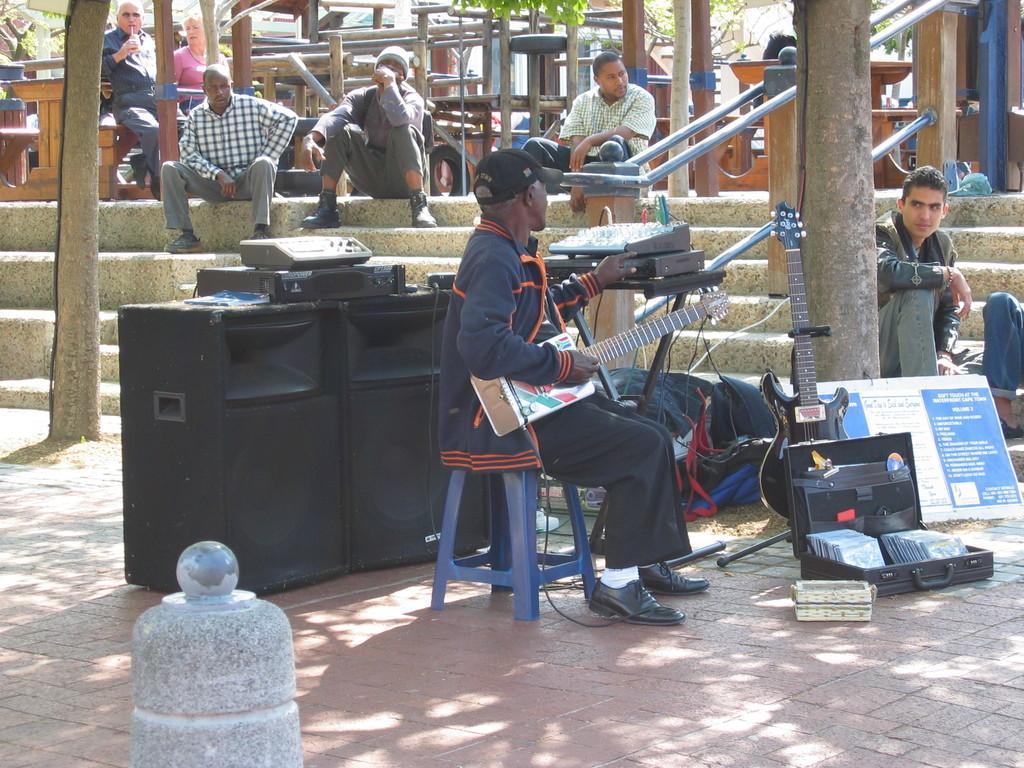Please provide a concise description of this image. In this image I can see group of people sitting. In front the person is sitting and holding the musical instrument. In the background I can see few wooden objects and I can also see few plants in green color. 